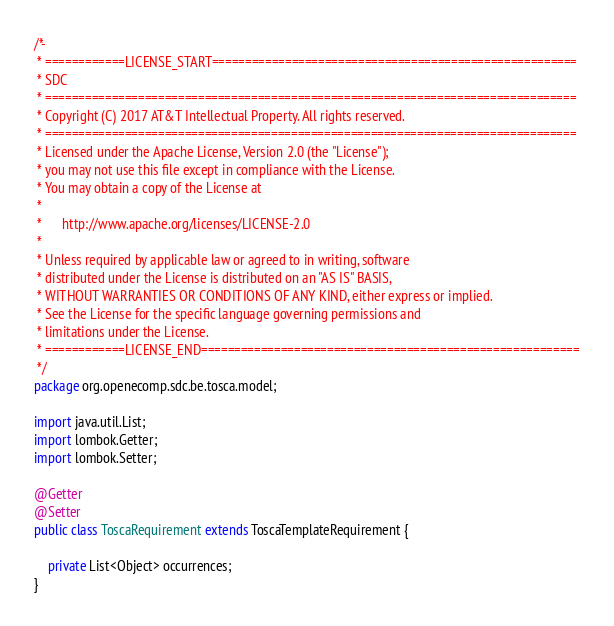Convert code to text. <code><loc_0><loc_0><loc_500><loc_500><_Java_>/*-
 * ============LICENSE_START=======================================================
 * SDC
 * ================================================================================
 * Copyright (C) 2017 AT&T Intellectual Property. All rights reserved.
 * ================================================================================
 * Licensed under the Apache License, Version 2.0 (the "License");
 * you may not use this file except in compliance with the License.
 * You may obtain a copy of the License at
 *
 *      http://www.apache.org/licenses/LICENSE-2.0
 *
 * Unless required by applicable law or agreed to in writing, software
 * distributed under the License is distributed on an "AS IS" BASIS,
 * WITHOUT WARRANTIES OR CONDITIONS OF ANY KIND, either express or implied.
 * See the License for the specific language governing permissions and
 * limitations under the License.
 * ============LICENSE_END=========================================================
 */
package org.openecomp.sdc.be.tosca.model;

import java.util.List;
import lombok.Getter;
import lombok.Setter;

@Getter
@Setter
public class ToscaRequirement extends ToscaTemplateRequirement {

    private List<Object> occurrences;
}
</code> 